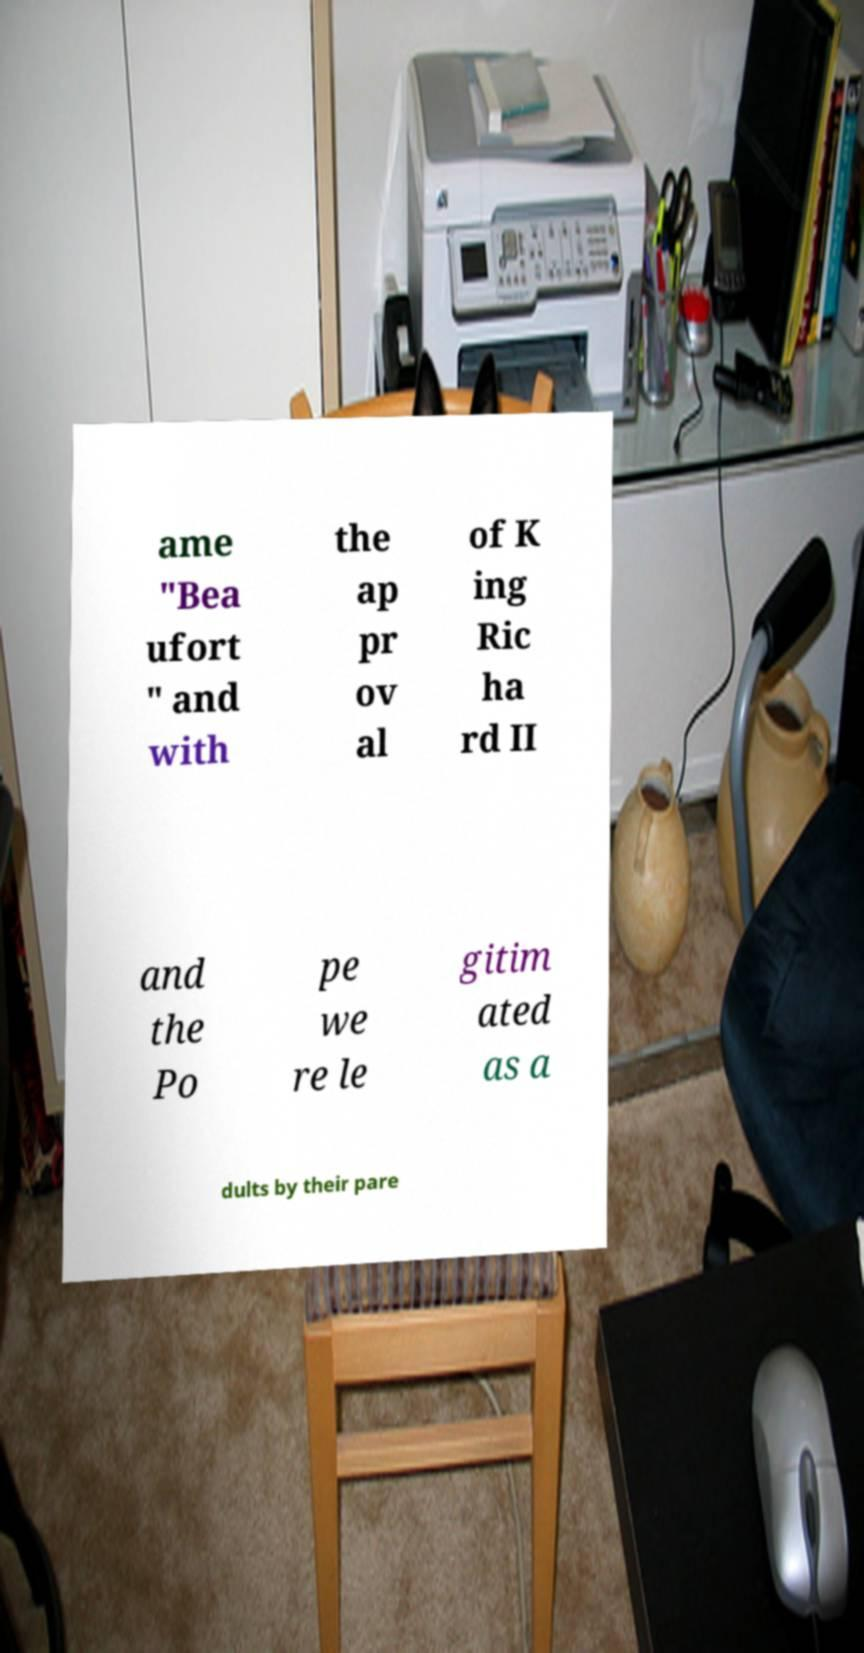What messages or text are displayed in this image? I need them in a readable, typed format. ame "Bea ufort " and with the ap pr ov al of K ing Ric ha rd II and the Po pe we re le gitim ated as a dults by their pare 